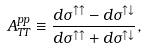<formula> <loc_0><loc_0><loc_500><loc_500>A _ { T T } ^ { p p } \equiv \frac { d \sigma ^ { \uparrow \uparrow } - d \sigma ^ { \uparrow \downarrow } } { d \sigma ^ { \uparrow \uparrow } + d \sigma ^ { \uparrow \downarrow } } ,</formula> 